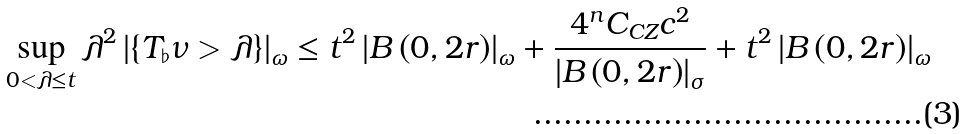Convert formula to latex. <formula><loc_0><loc_0><loc_500><loc_500>\sup _ { 0 < \lambda \leq t } \lambda ^ { 2 } \left | \left \{ T _ { \flat } \nu > \lambda \right \} \right | _ { \omega } \leq t ^ { 2 } \left | B \left ( 0 , 2 r \right ) \right | _ { \omega } + \frac { 4 ^ { n } C _ { C Z } c ^ { 2 } } { \left | B \left ( 0 , 2 r \right ) \right | _ { \sigma } } + t ^ { 2 } \left | B \left ( 0 , 2 r \right ) \right | _ { \omega }</formula> 